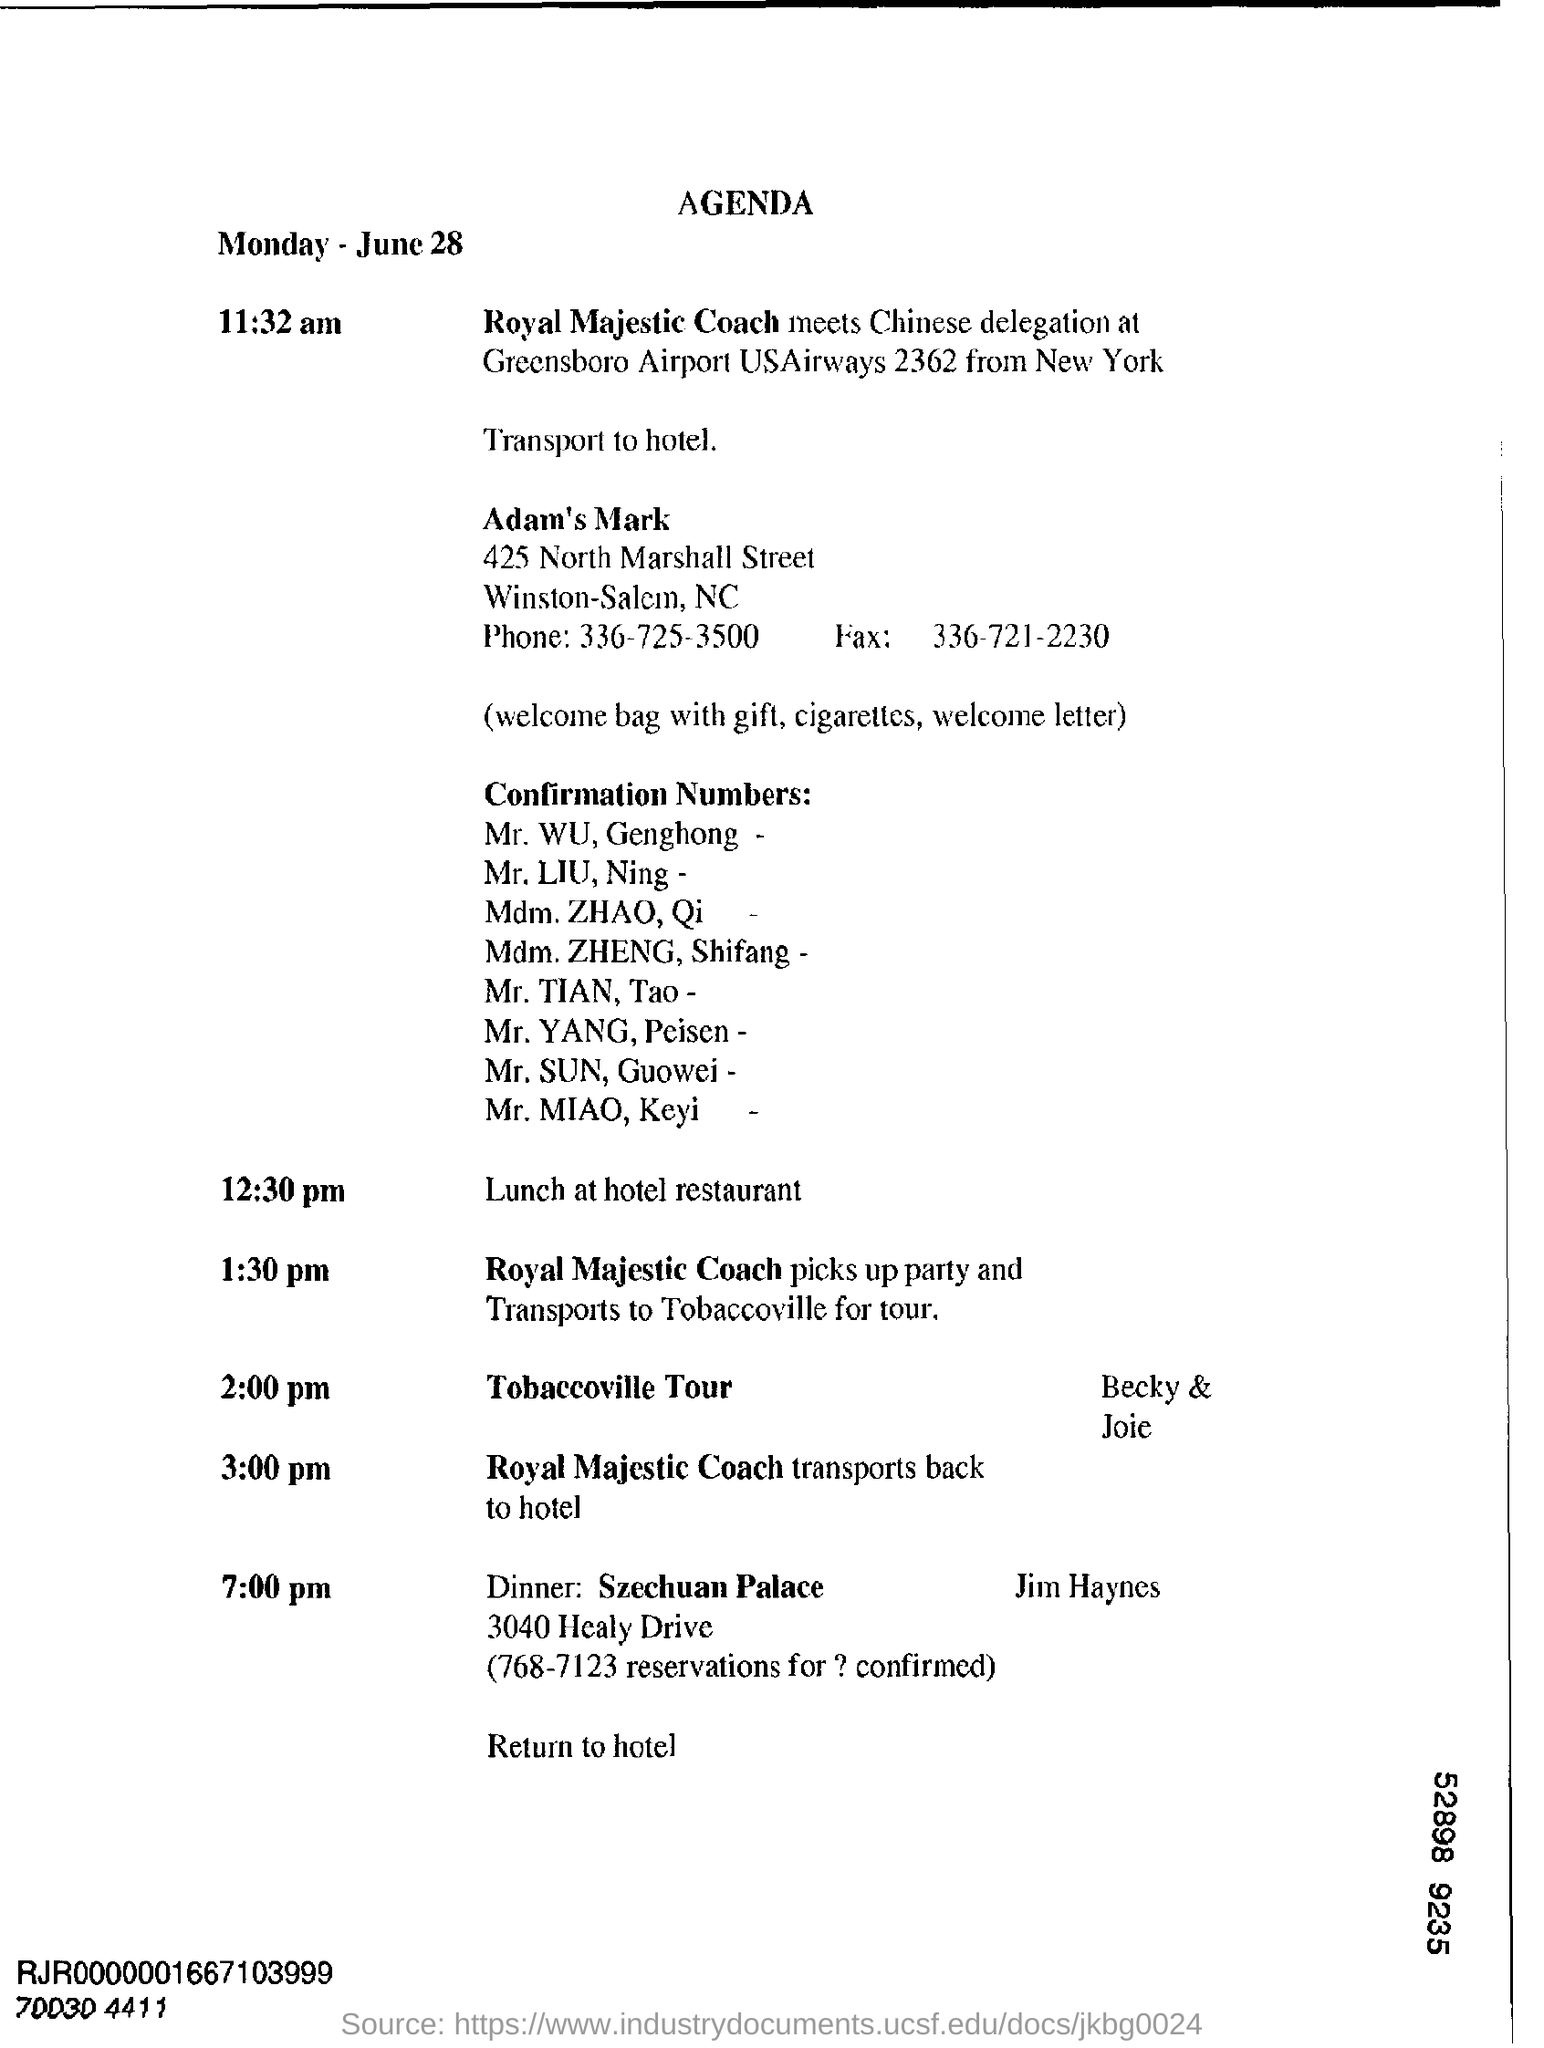What is the Title of the document ?
Offer a very short reply. Agenda. What is the date mentioned in the top of the document ?
Provide a succinct answer. June 28. What is the Fax Number ?
Offer a very short reply. 336-721-2230. What is the Phone Number ?
Make the answer very short. 336-725-3500. 